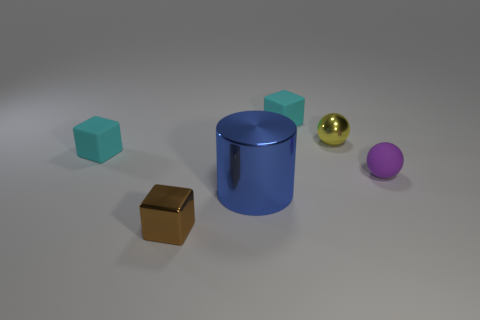Is the color of the rubber block that is left of the blue object the same as the tiny cube that is behind the tiny yellow metal thing?
Keep it short and to the point. Yes. Are there any other things that are the same size as the blue thing?
Your response must be concise. No. What is the shape of the large blue thing?
Provide a short and direct response. Cylinder. What material is the thing that is on the left side of the big metallic thing and in front of the purple rubber sphere?
Ensure brevity in your answer.  Metal. What shape is the big blue thing that is the same material as the small brown thing?
Provide a succinct answer. Cylinder. There is a ball that is made of the same material as the brown block; what is its size?
Make the answer very short. Small. There is a rubber thing that is to the right of the big shiny thing and left of the purple rubber object; what is its shape?
Ensure brevity in your answer.  Cube. How big is the cyan object that is in front of the tiny rubber thing that is behind the small yellow ball?
Ensure brevity in your answer.  Small. What is the tiny yellow sphere made of?
Keep it short and to the point. Metal. Are there any green rubber blocks?
Provide a short and direct response. No. 